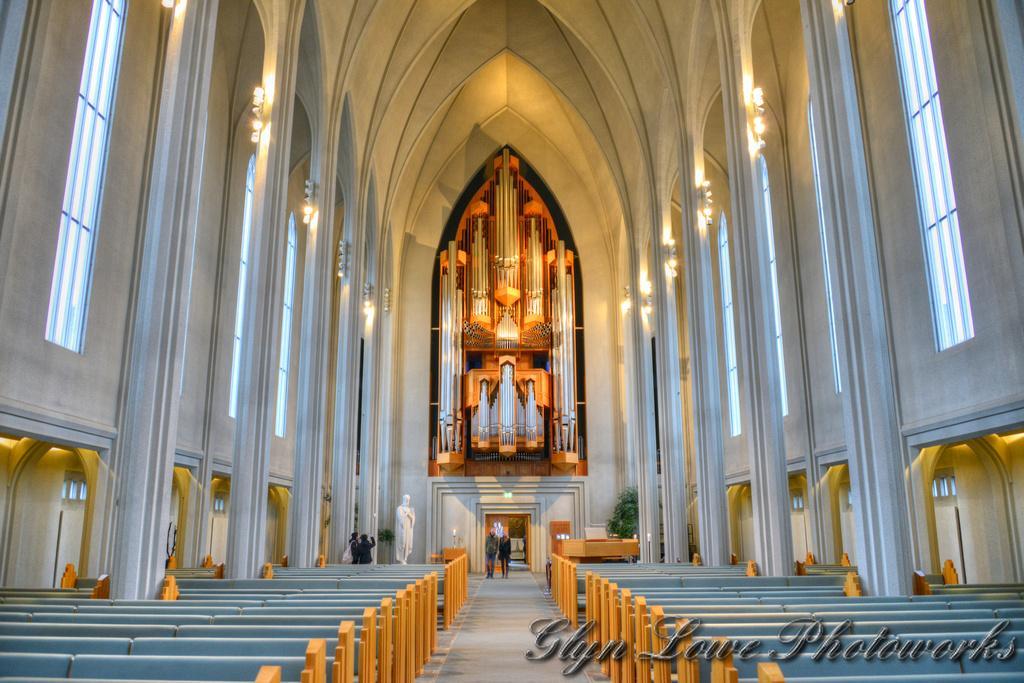Describe this image in one or two sentences. In the picture I can see the cathedral construction. I can see the benches on the left side and the right side as well. I can see the walkway in the middle of the image and I can see two persons walking on the walkway. I can see two persons on the left side. I can see the glass windows and lighting arrangement on the left side and the right side as well. 